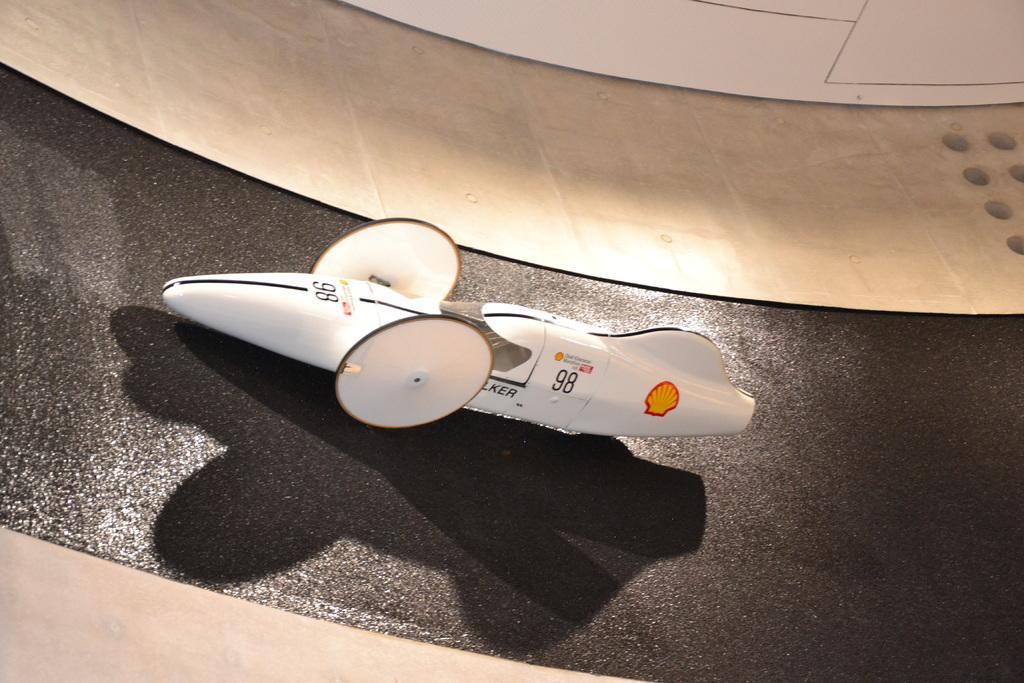Can you describe this image briefly? This image consists of a toy car. At the bottom, we can see a black colored surface. 